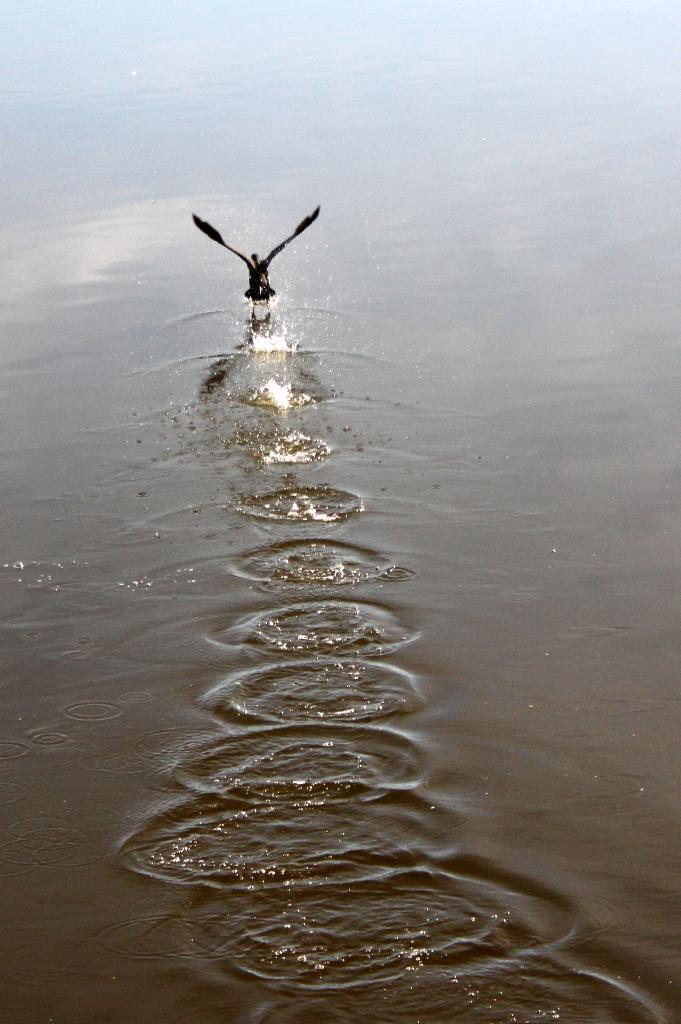What animal can be seen in the image? There is a bird in the image. What is the bird doing in the image? The bird is flying. Over what type of surface is the bird flying? The bird is flying over water. What can be observed about the water in the background? There are ripples in the water in the background. What type of stone is the bird holding in its beak in the image? There is no stone present in the image; the bird is flying over water. 